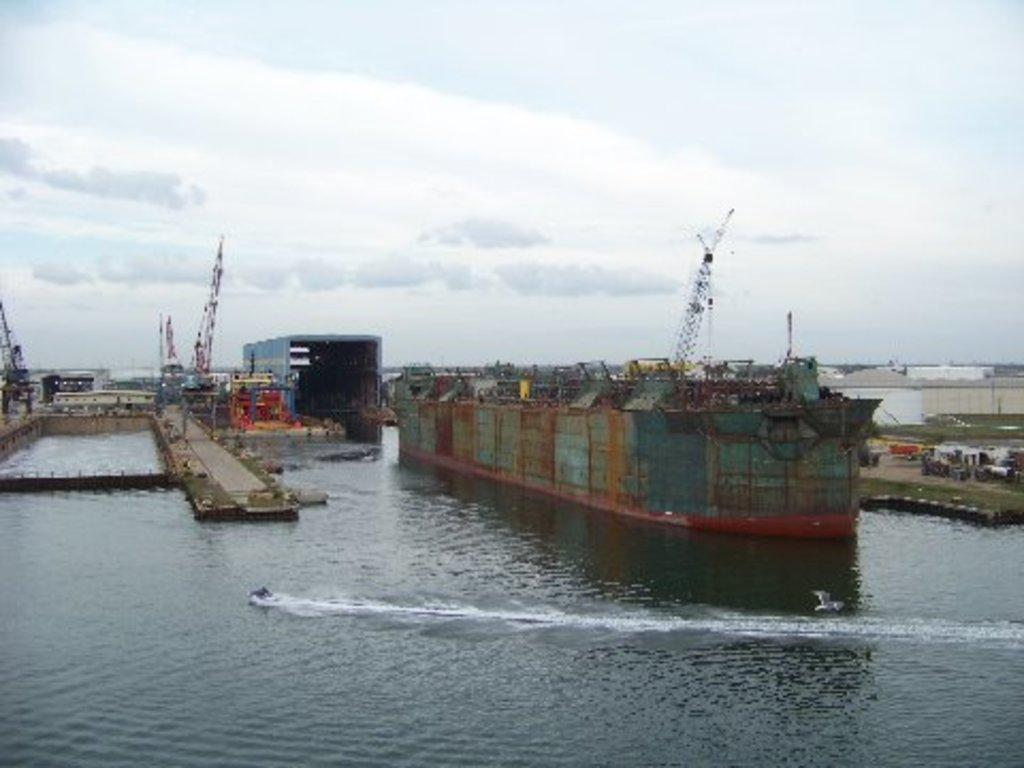What is the main subject of the image? There is a ship on the water in the image. What can be seen on the ship? There are boats on the ship. What is visible in the background of the image? There are buildings, grass, and other objects on the ground in the background. What is the condition of the sky in the image? There are clouds in the sky in the image. What type of poison can be seen in the image? There is no poison present in the image. Can you tell me how many times the ship is crushed in the image? The ship is not crushed in the image; it is sailing on the water. 